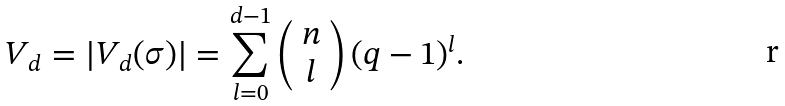<formula> <loc_0><loc_0><loc_500><loc_500>V _ { d } = | V _ { d } ( \sigma ) | = \sum _ { l = 0 } ^ { d - 1 } \left ( \begin{array} { c } n \\ l \end{array} \right ) ( q - 1 ) ^ { l } .</formula> 